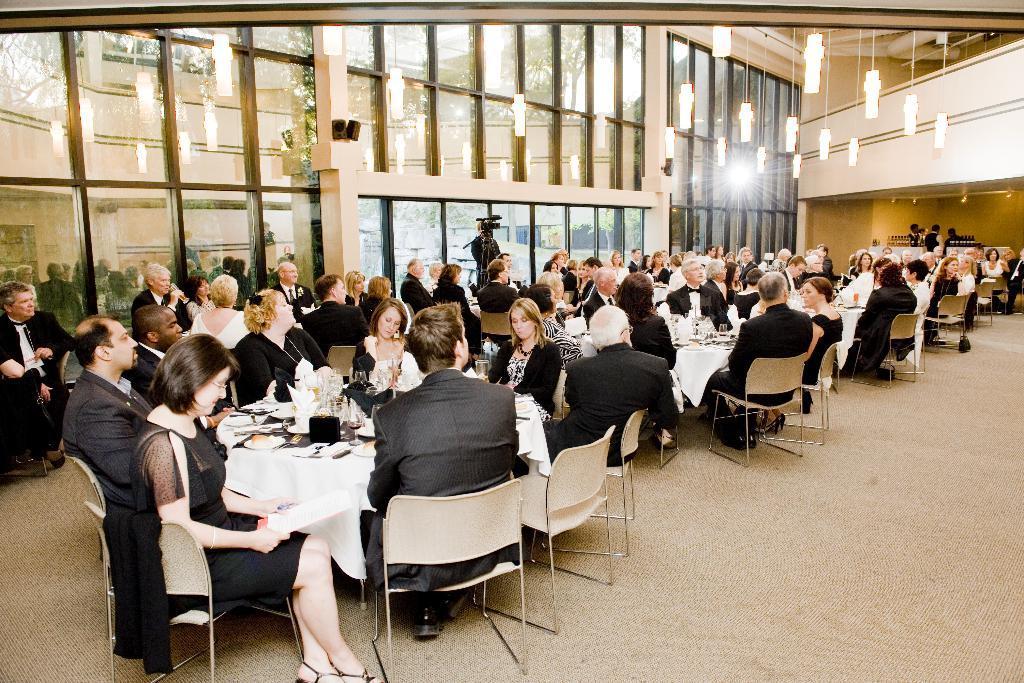In one or two sentences, can you explain what this image depicts? This picture shows a group of people seated on the chairs and we see a man standing with a camera and we see a light 